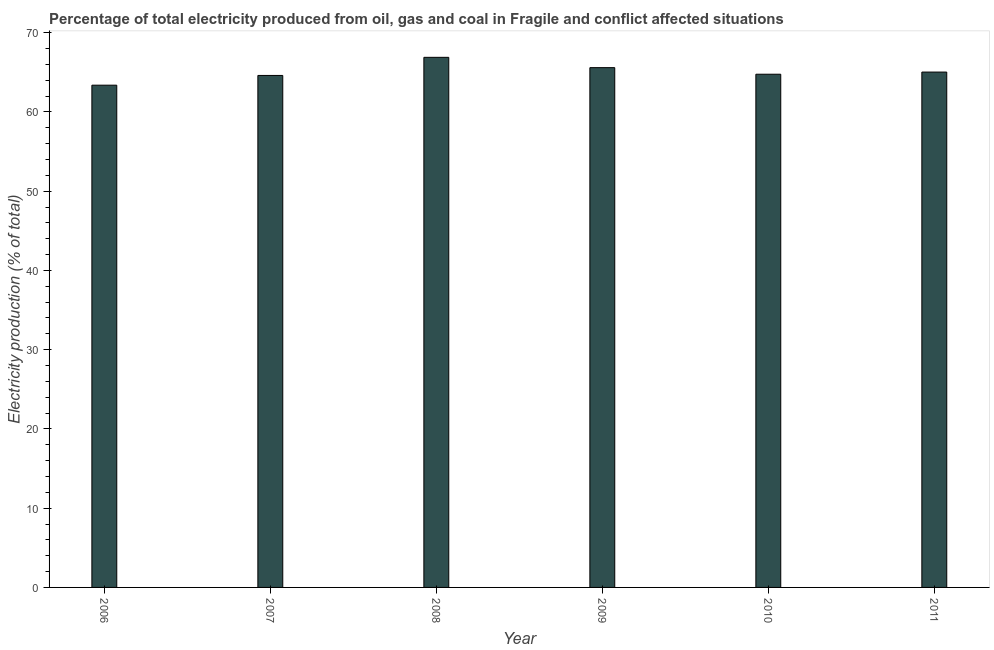Does the graph contain any zero values?
Provide a succinct answer. No. Does the graph contain grids?
Offer a terse response. No. What is the title of the graph?
Give a very brief answer. Percentage of total electricity produced from oil, gas and coal in Fragile and conflict affected situations. What is the label or title of the Y-axis?
Your response must be concise. Electricity production (% of total). What is the electricity production in 2010?
Provide a succinct answer. 64.76. Across all years, what is the maximum electricity production?
Give a very brief answer. 66.89. Across all years, what is the minimum electricity production?
Offer a terse response. 63.38. What is the sum of the electricity production?
Provide a short and direct response. 390.25. What is the difference between the electricity production in 2007 and 2009?
Your response must be concise. -0.98. What is the average electricity production per year?
Your answer should be compact. 65.04. What is the median electricity production?
Give a very brief answer. 64.89. Do a majority of the years between 2010 and 2007 (inclusive) have electricity production greater than 40 %?
Keep it short and to the point. Yes. What is the ratio of the electricity production in 2007 to that in 2008?
Provide a short and direct response. 0.97. What is the difference between the highest and the second highest electricity production?
Keep it short and to the point. 1.3. What is the difference between the highest and the lowest electricity production?
Give a very brief answer. 3.51. What is the Electricity production (% of total) of 2006?
Keep it short and to the point. 63.38. What is the Electricity production (% of total) in 2007?
Offer a terse response. 64.61. What is the Electricity production (% of total) in 2008?
Provide a short and direct response. 66.89. What is the Electricity production (% of total) of 2009?
Provide a succinct answer. 65.59. What is the Electricity production (% of total) in 2010?
Your response must be concise. 64.76. What is the Electricity production (% of total) in 2011?
Give a very brief answer. 65.03. What is the difference between the Electricity production (% of total) in 2006 and 2007?
Make the answer very short. -1.23. What is the difference between the Electricity production (% of total) in 2006 and 2008?
Make the answer very short. -3.51. What is the difference between the Electricity production (% of total) in 2006 and 2009?
Provide a short and direct response. -2.21. What is the difference between the Electricity production (% of total) in 2006 and 2010?
Provide a short and direct response. -1.38. What is the difference between the Electricity production (% of total) in 2006 and 2011?
Offer a very short reply. -1.65. What is the difference between the Electricity production (% of total) in 2007 and 2008?
Your answer should be compact. -2.29. What is the difference between the Electricity production (% of total) in 2007 and 2009?
Provide a succinct answer. -0.98. What is the difference between the Electricity production (% of total) in 2007 and 2010?
Your answer should be very brief. -0.15. What is the difference between the Electricity production (% of total) in 2007 and 2011?
Offer a terse response. -0.43. What is the difference between the Electricity production (% of total) in 2008 and 2009?
Your answer should be compact. 1.3. What is the difference between the Electricity production (% of total) in 2008 and 2010?
Provide a succinct answer. 2.13. What is the difference between the Electricity production (% of total) in 2008 and 2011?
Provide a short and direct response. 1.86. What is the difference between the Electricity production (% of total) in 2009 and 2010?
Your answer should be compact. 0.83. What is the difference between the Electricity production (% of total) in 2009 and 2011?
Offer a terse response. 0.56. What is the difference between the Electricity production (% of total) in 2010 and 2011?
Provide a succinct answer. -0.27. What is the ratio of the Electricity production (% of total) in 2006 to that in 2008?
Provide a succinct answer. 0.95. What is the ratio of the Electricity production (% of total) in 2006 to that in 2009?
Your answer should be compact. 0.97. What is the ratio of the Electricity production (% of total) in 2006 to that in 2011?
Your response must be concise. 0.97. What is the ratio of the Electricity production (% of total) in 2007 to that in 2008?
Your response must be concise. 0.97. What is the ratio of the Electricity production (% of total) in 2007 to that in 2011?
Your answer should be compact. 0.99. What is the ratio of the Electricity production (% of total) in 2008 to that in 2009?
Offer a very short reply. 1.02. What is the ratio of the Electricity production (% of total) in 2008 to that in 2010?
Your response must be concise. 1.03. What is the ratio of the Electricity production (% of total) in 2008 to that in 2011?
Keep it short and to the point. 1.03. What is the ratio of the Electricity production (% of total) in 2009 to that in 2010?
Offer a terse response. 1.01. What is the ratio of the Electricity production (% of total) in 2009 to that in 2011?
Ensure brevity in your answer.  1.01. What is the ratio of the Electricity production (% of total) in 2010 to that in 2011?
Provide a short and direct response. 1. 